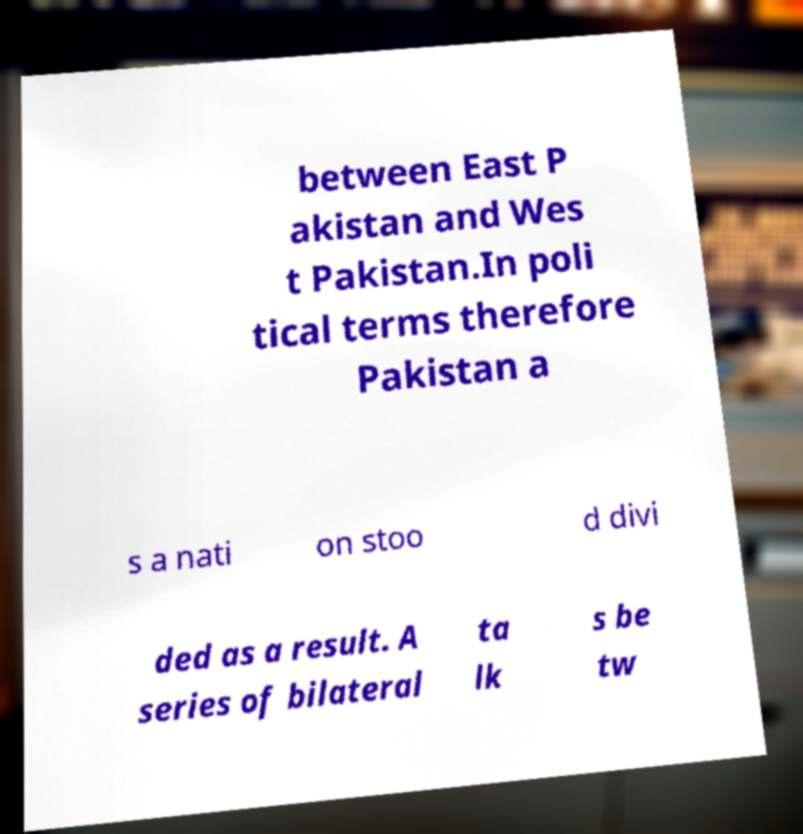Can you accurately transcribe the text from the provided image for me? between East P akistan and Wes t Pakistan.In poli tical terms therefore Pakistan a s a nati on stoo d divi ded as a result. A series of bilateral ta lk s be tw 